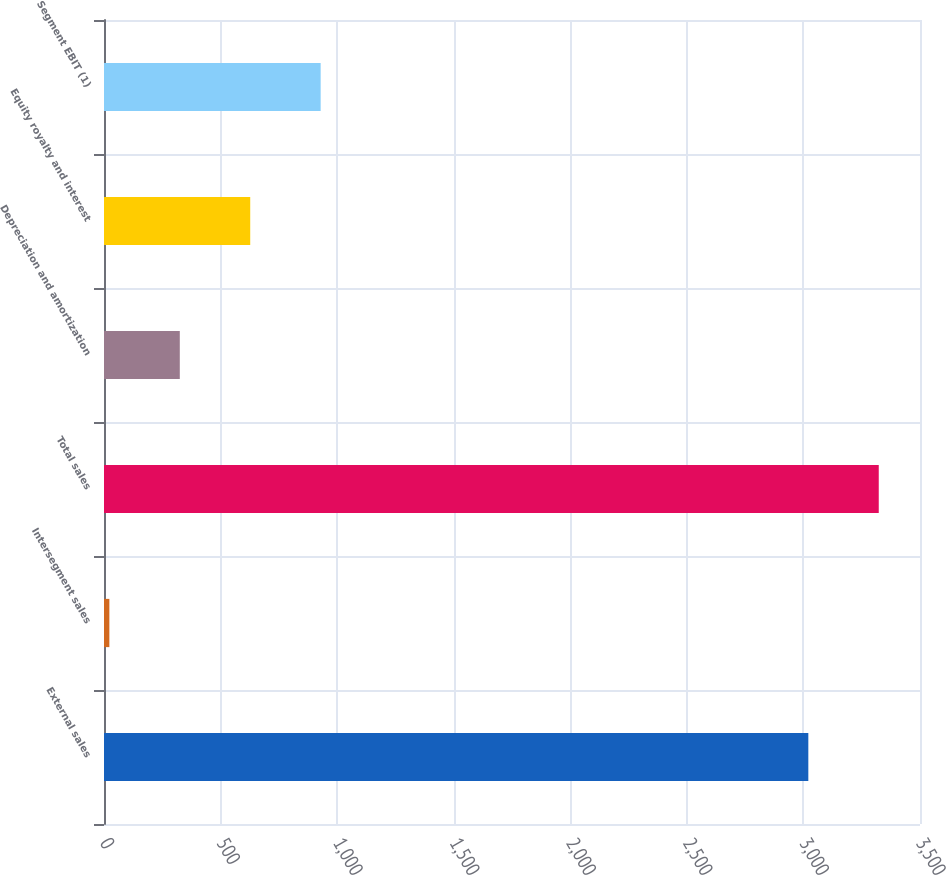Convert chart to OTSL. <chart><loc_0><loc_0><loc_500><loc_500><bar_chart><fcel>External sales<fcel>Intersegment sales<fcel>Total sales<fcel>Depreciation and amortization<fcel>Equity royalty and interest<fcel>Segment EBIT (1)<nl><fcel>3021<fcel>23<fcel>3323.1<fcel>325.1<fcel>627.2<fcel>929.3<nl></chart> 